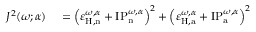Convert formula to latex. <formula><loc_0><loc_0><loc_500><loc_500>\begin{array} { r l } { J ^ { 2 } ( \omega ; \alpha ) } & = \left ( \varepsilon _ { H , n } ^ { \omega , \alpha } + I P _ { n } ^ { \omega , \alpha } \right ) ^ { 2 } + \left ( \varepsilon _ { H , a } ^ { \omega , \alpha } + I P _ { a } ^ { \omega , \alpha } \right ) ^ { 2 } } \end{array}</formula> 